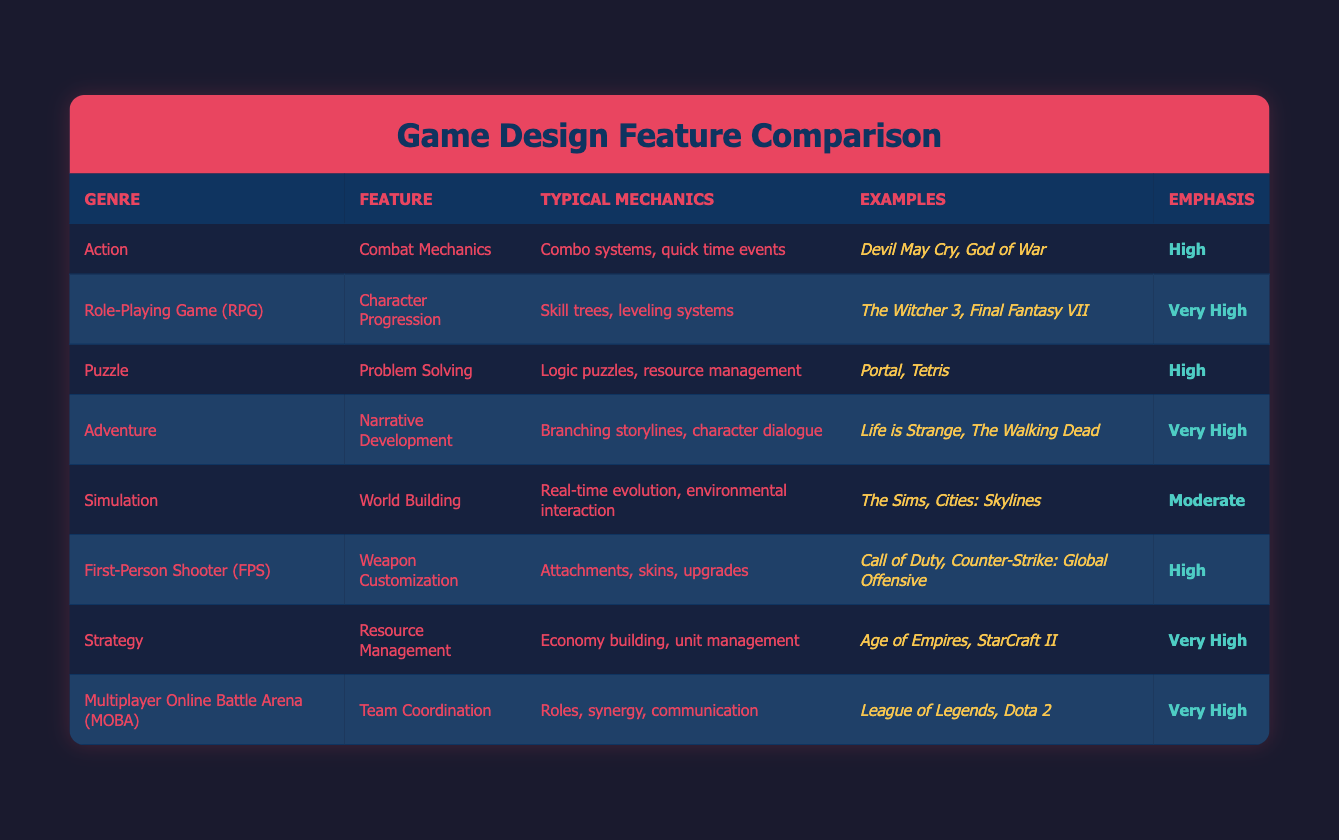What is the emphasis on "Character Progression" in RPGs? The emphasis on "Character Progression" in RPGs is listed in the table as "Very High." This can be directly retrieved from the emphasis column corresponding to the RPG genre.
Answer: Very High Which genre has "Team Coordination" as a feature? "Team Coordination" is listed as a feature under the "Multiplayer Online Battle Arena (MOBA)" genre. This is found in the feature column where MOBA is the genre.
Answer: Multiplayer Online Battle Arena (MOBA) How many genres have a "High" emphasis on features? From the table, the genres with a "High" emphasis are Action, Puzzle, and First-Person Shooter (FPS). Counting these genres gives us a total of 3.
Answer: 3 Is "World Building" considered to have a very high emphasis? The table indicates that "World Building" has a "Moderate" emphasis. This means that it is not considered to have a very high emphasis.
Answer: No Which feature is associated with the greatest number of high emphasis genres? Analyzing the emphasis levels, "Character Progression," "Resource Management," and "Team Coordination" are all in genres with "Very High" emphasis. Since we have 3 genres for "Very High" and only 1 for "Moderate," the answer is these three features associated with "Very High" emphasis.
Answer: Character Progression, Resource Management, Team Coordination What are the typical mechanics of "Weapon Customization"? The typical mechanics of "Weapon Customization" are listed as "Attachments, skins, upgrades." This can be found in the typical mechanics column under the First-Person Shooter (FPS) genre.
Answer: Attachments, skins, upgrades Which genre has examples including "The Witcher 3"? "The Witcher 3" is mentioned as an example of the genre "Role-Playing Game (RPG)", found directly in the examples column corresponding to that genre.
Answer: Role-Playing Game (RPG) What is the difference in emphasis between "World Building" and "Narrative Development"? "World Building" has a "Moderate" emphasis while "Narrative Development" has a "Very High" emphasis. The difference is "Very High" minus "Moderate." This indicates that "Narrative Development" is emphasized significantly more than "World Building."
Answer: Very High to Moderate difference How do the typical mechanics of the Puzzle genre compare to the Adventure genre? The typical mechanics of the Puzzle genre are "Logic puzzles, resource management," while for the Adventure genre, they are "Branching storylines, character dialogue." The comparison shows that Puzzle focuses on problem-solving techniques while Adventure emphasizes story development and character interactions. Both mechanics cater to different player experiences.
Answer: Different focus (Puzzle: problem-solving, Adventure: narrative development) 